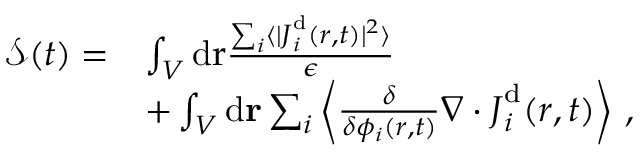<formula> <loc_0><loc_0><loc_500><loc_500>\begin{array} { r l } { { \mathcal { S } } ( t ) = } & { \int _ { V } d { r } \frac { \sum _ { i } \langle | { J } _ { i } ^ { d } ( { r } , t ) | ^ { 2 } \rangle } { \epsilon } } \\ & { + \int _ { V } d r \sum _ { i } \left \langle \frac { \delta } { \delta { \phi _ { i } ( r , t ) } } \nabla \cdot { J } _ { i } ^ { d } ( { r } , t ) \right \rangle \, , } \end{array}</formula> 